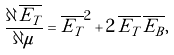Convert formula to latex. <formula><loc_0><loc_0><loc_500><loc_500>\frac { \partial \, \overline { E _ { T } } } { \partial \mu } = \overline { E _ { T } } ^ { 2 } + 2 \, \overline { E _ { T } } \, \overline { E _ { B } } ,</formula> 